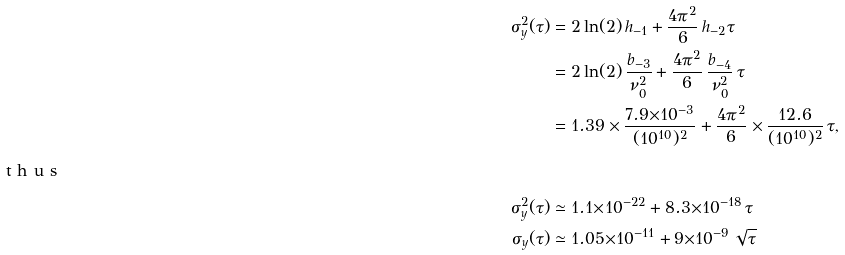<formula> <loc_0><loc_0><loc_500><loc_500>\sigma ^ { 2 } _ { y } ( \tau ) & = 2 \ln ( 2 ) \, h _ { - 1 } + \frac { 4 \pi ^ { 2 } } { 6 } \, h _ { - 2 } \tau \\ & = 2 \ln ( 2 ) \, \frac { b _ { - 3 } } { \nu _ { 0 } ^ { 2 } } + \frac { 4 \pi ^ { 2 } } { 6 } \, \frac { b _ { - 4 } } { \nu _ { 0 } ^ { 2 } } \, \tau \\ & = 1 . 3 9 \times \frac { 7 . 9 { \times } 1 0 ^ { - 3 } } { ( 1 0 ^ { 1 0 } ) ^ { 2 } } + \frac { 4 \pi ^ { 2 } } { 6 } \times \frac { 1 2 . 6 } { ( 1 0 ^ { 1 0 } ) ^ { 2 } } \, \tau , \intertext { t h u s } \sigma ^ { 2 } _ { y } ( \tau ) & \simeq 1 . 1 { \times } 1 0 ^ { - 2 2 } + 8 . 3 { \times } 1 0 ^ { - 1 8 } \, \tau \\ \sigma _ { y } ( \tau ) & \simeq 1 . 0 5 { \times } 1 0 ^ { - 1 1 } + 9 { \times } 1 0 ^ { - 9 } \, \sqrt { \tau }</formula> 